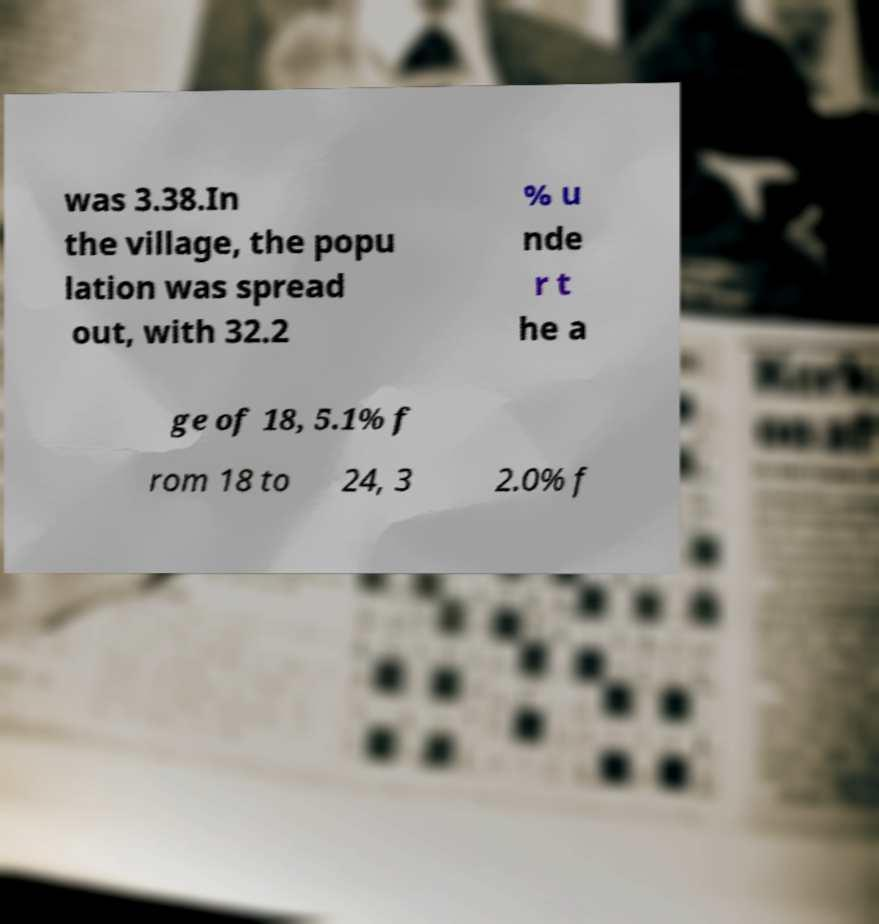Could you extract and type out the text from this image? was 3.38.In the village, the popu lation was spread out, with 32.2 % u nde r t he a ge of 18, 5.1% f rom 18 to 24, 3 2.0% f 